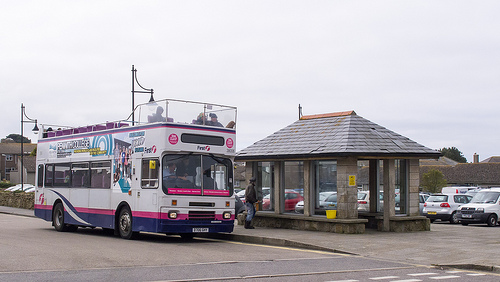Who is the bus carrying? The bus is carrying people. 